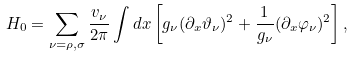Convert formula to latex. <formula><loc_0><loc_0><loc_500><loc_500>H _ { 0 } = \sum _ { \nu = \rho , \sigma } \frac { v _ { \nu } } { 2 \pi } \int d x \left [ g _ { \nu } ( \partial _ { x } \vartheta _ { \nu } ) ^ { 2 } + \frac { 1 } { g _ { \nu } } ( \partial _ { x } \varphi _ { \nu } ) ^ { 2 } \right ] ,</formula> 